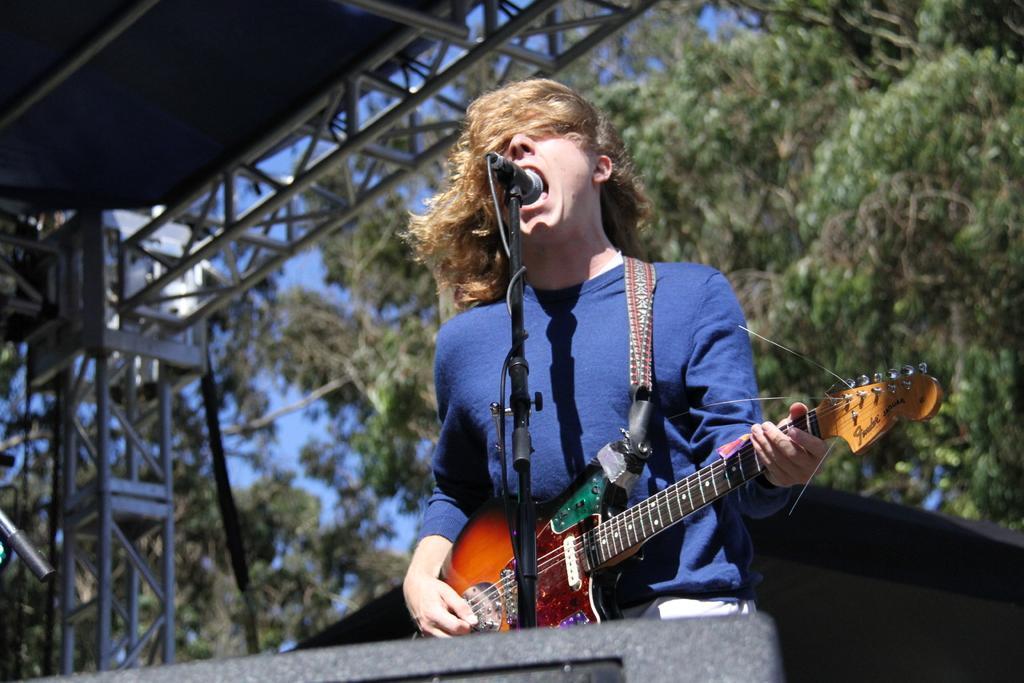Please provide a concise description of this image. In the middle of the image a person is standing and playing guitar and singing on the microphone. Top right side of the image there are some trees. Top left side of the image there is a roof. 